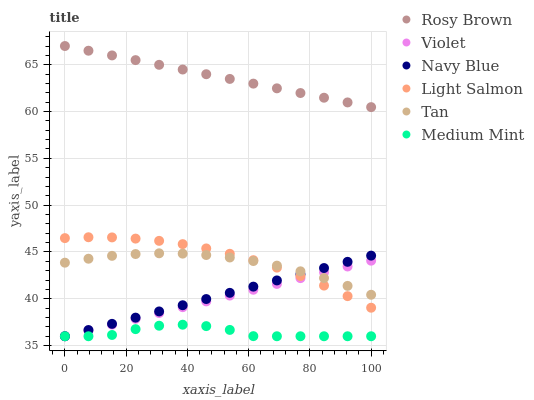Does Medium Mint have the minimum area under the curve?
Answer yes or no. Yes. Does Rosy Brown have the maximum area under the curve?
Answer yes or no. Yes. Does Light Salmon have the minimum area under the curve?
Answer yes or no. No. Does Light Salmon have the maximum area under the curve?
Answer yes or no. No. Is Navy Blue the smoothest?
Answer yes or no. Yes. Is Medium Mint the roughest?
Answer yes or no. Yes. Is Light Salmon the smoothest?
Answer yes or no. No. Is Light Salmon the roughest?
Answer yes or no. No. Does Medium Mint have the lowest value?
Answer yes or no. Yes. Does Light Salmon have the lowest value?
Answer yes or no. No. Does Rosy Brown have the highest value?
Answer yes or no. Yes. Does Light Salmon have the highest value?
Answer yes or no. No. Is Medium Mint less than Rosy Brown?
Answer yes or no. Yes. Is Rosy Brown greater than Tan?
Answer yes or no. Yes. Does Light Salmon intersect Tan?
Answer yes or no. Yes. Is Light Salmon less than Tan?
Answer yes or no. No. Is Light Salmon greater than Tan?
Answer yes or no. No. Does Medium Mint intersect Rosy Brown?
Answer yes or no. No. 